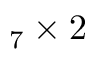<formula> <loc_0><loc_0><loc_500><loc_500>_ { 7 } \times 2</formula> 